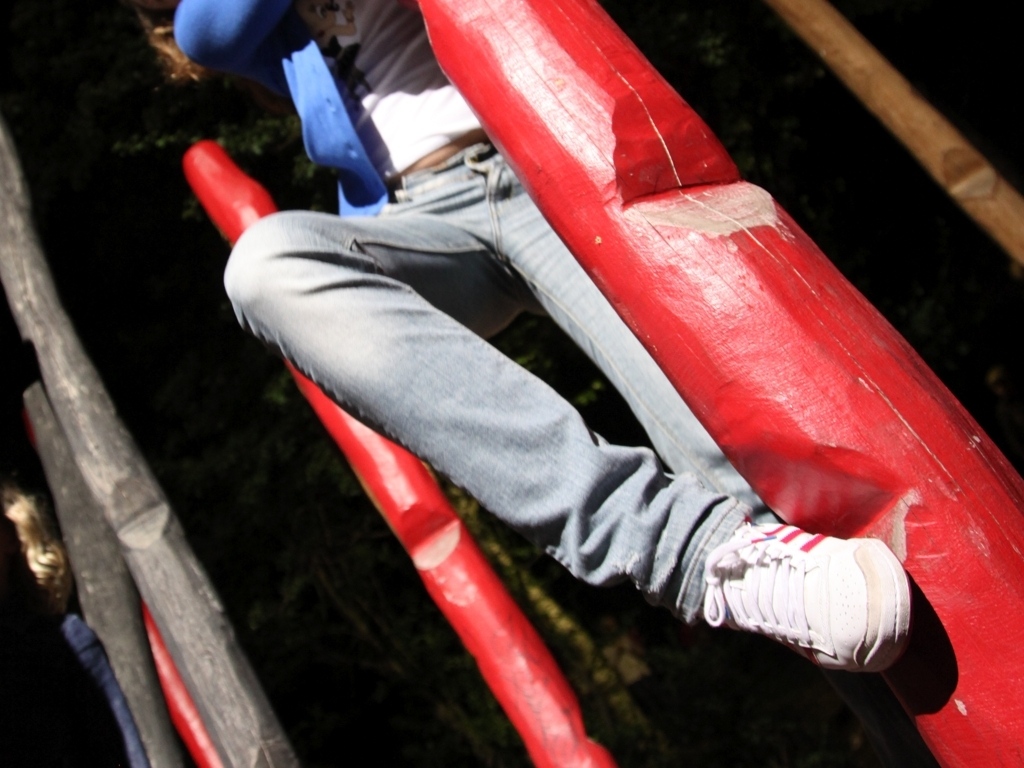What can you infer about the setting beyond the immediate focus of the image? While the main focus is on the red bars and the person's attire, the presence of abundant greenery in the background hints at a lush, possibly wooded area that surrounds the play structure or adventure setup. 